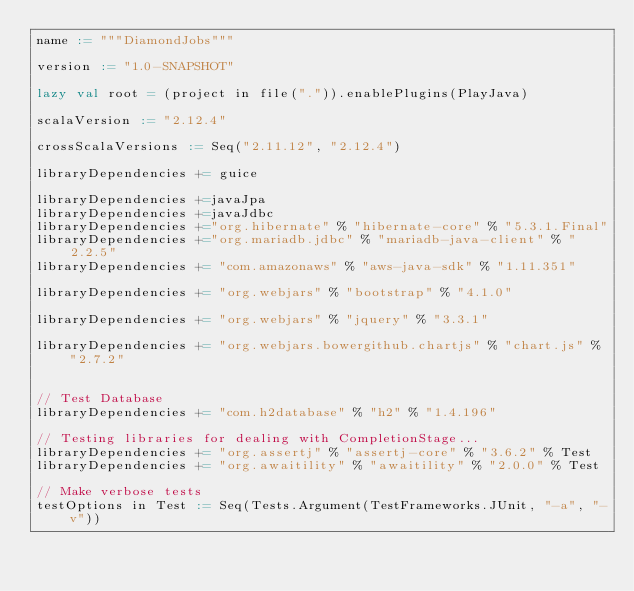<code> <loc_0><loc_0><loc_500><loc_500><_Scala_>name := """DiamondJobs"""

version := "1.0-SNAPSHOT"

lazy val root = (project in file(".")).enablePlugins(PlayJava)

scalaVersion := "2.12.4"

crossScalaVersions := Seq("2.11.12", "2.12.4")

libraryDependencies += guice

libraryDependencies +=javaJpa
libraryDependencies +=javaJdbc
libraryDependencies +="org.hibernate" % "hibernate-core" % "5.3.1.Final"
libraryDependencies +="org.mariadb.jdbc" % "mariadb-java-client" % "2.2.5"
libraryDependencies += "com.amazonaws" % "aws-java-sdk" % "1.11.351"

libraryDependencies += "org.webjars" % "bootstrap" % "4.1.0"

libraryDependencies += "org.webjars" % "jquery" % "3.3.1"

libraryDependencies += "org.webjars.bowergithub.chartjs" % "chart.js" % "2.7.2"


// Test Database
libraryDependencies += "com.h2database" % "h2" % "1.4.196"

// Testing libraries for dealing with CompletionStage...
libraryDependencies += "org.assertj" % "assertj-core" % "3.6.2" % Test
libraryDependencies += "org.awaitility" % "awaitility" % "2.0.0" % Test

// Make verbose tests
testOptions in Test := Seq(Tests.Argument(TestFrameworks.JUnit, "-a", "-v"))
</code> 